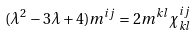<formula> <loc_0><loc_0><loc_500><loc_500>( \lambda ^ { 2 } - 3 \lambda + 4 ) m ^ { i j } = 2 m ^ { k l } \chi ^ { i j } _ { k l }</formula> 